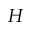Convert formula to latex. <formula><loc_0><loc_0><loc_500><loc_500>H</formula> 